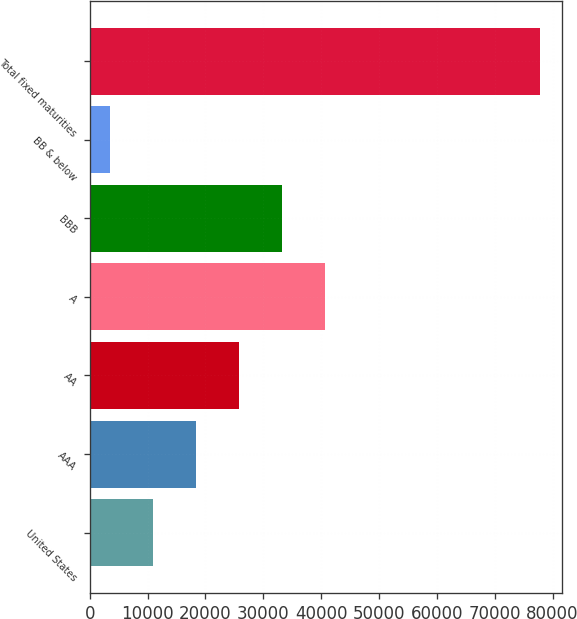Convert chart to OTSL. <chart><loc_0><loc_0><loc_500><loc_500><bar_chart><fcel>United States<fcel>AAA<fcel>AA<fcel>A<fcel>BBB<fcel>BB & below<fcel>Total fixed maturities<nl><fcel>10986.9<fcel>18412.8<fcel>25838.7<fcel>40690.5<fcel>33264.6<fcel>3561<fcel>77820<nl></chart> 